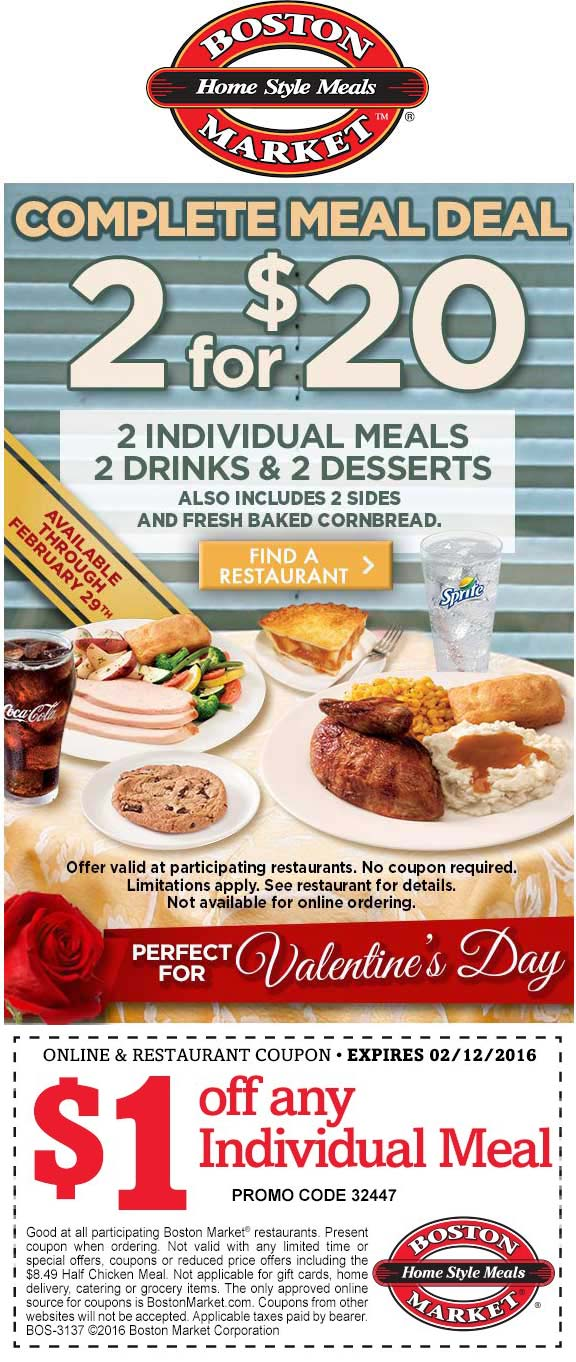How does the advertisement's design and imagery play a role in attracting the targeted consumer demographic for this deal? The design and imagery of the advertisement are meticulously crafted to attract individuals looking for cost-effective yet romantic dining options. The dominant red color scheme and visual elements such as roses and soft lighting evoke a sense of warmth and romance, which is appealing around Valentine’s Day. The visuals of a complete meal spread suggest a satisfying dining experience, appealing to couples or friends seeking a home-style meal without requiring the effort of home cooking. This design strategy likely aims to draw in consumers seeking both value and a special dining experience around a romantic holiday. 